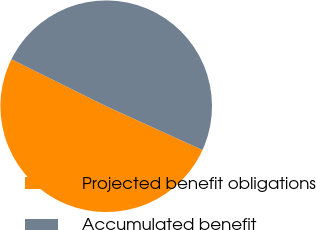<chart> <loc_0><loc_0><loc_500><loc_500><pie_chart><fcel>Projected benefit obligations<fcel>Accumulated benefit<nl><fcel>50.53%<fcel>49.47%<nl></chart> 